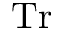Convert formula to latex. <formula><loc_0><loc_0><loc_500><loc_500>T r</formula> 